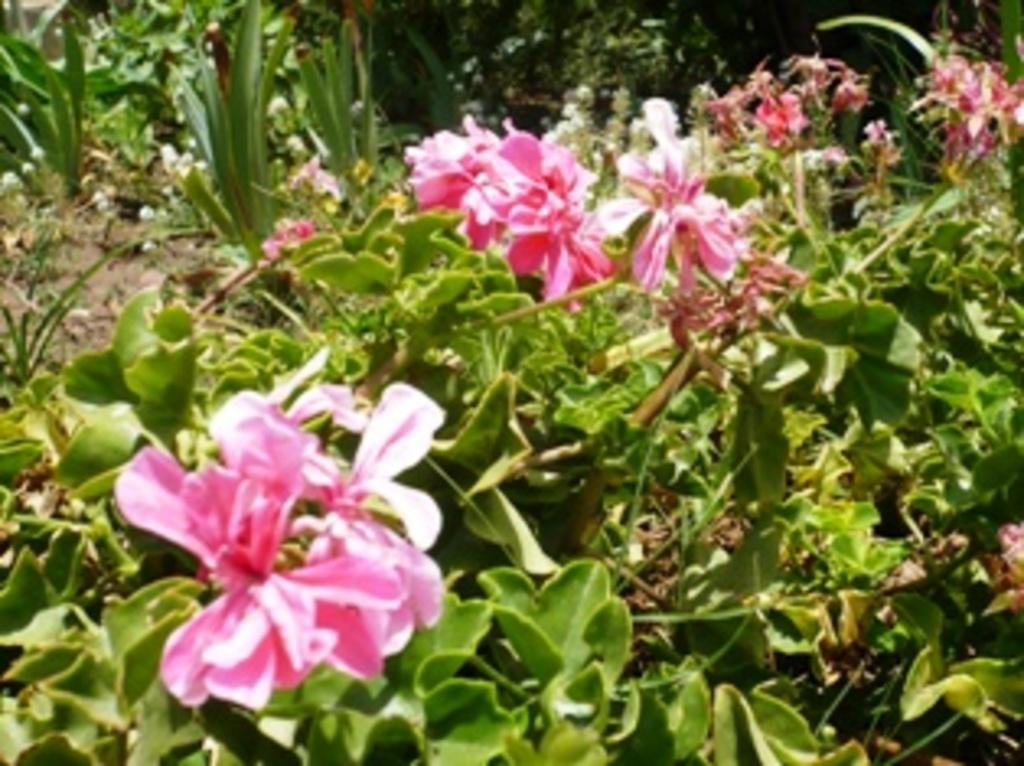What is the primary subject of the image? The primary subject of the image is many plants. What specific feature can be observed on the plants? The plants have flowers. What type of pump is used to water the plants in the image? There is no pump present in the image; it only shows plants with flowers. 